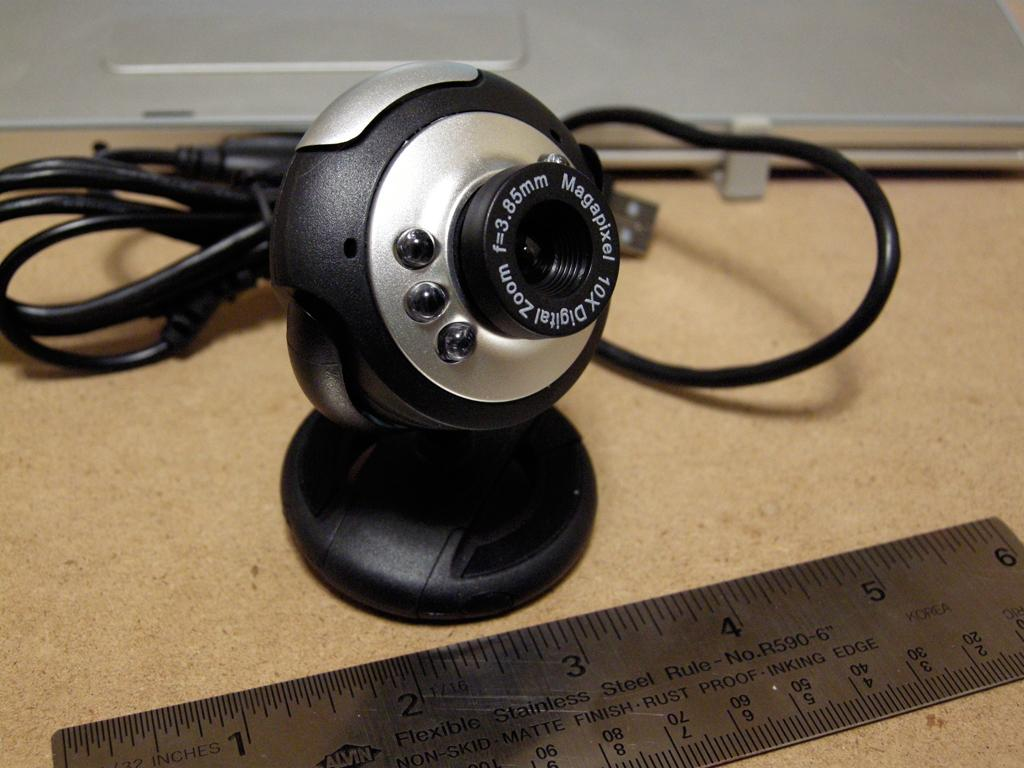Provide a one-sentence caption for the provided image. A webcam has a 10x digital zoom feature. 